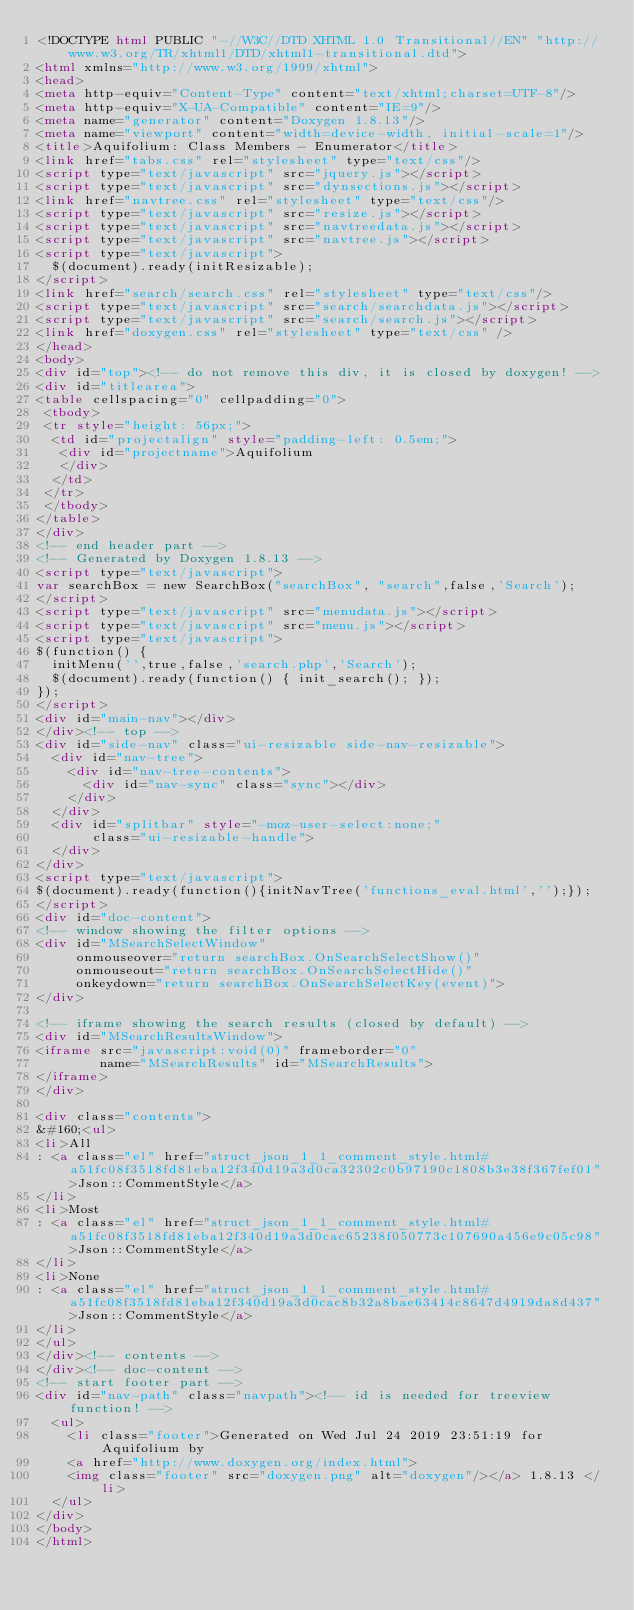Convert code to text. <code><loc_0><loc_0><loc_500><loc_500><_HTML_><!DOCTYPE html PUBLIC "-//W3C//DTD XHTML 1.0 Transitional//EN" "http://www.w3.org/TR/xhtml1/DTD/xhtml1-transitional.dtd">
<html xmlns="http://www.w3.org/1999/xhtml">
<head>
<meta http-equiv="Content-Type" content="text/xhtml;charset=UTF-8"/>
<meta http-equiv="X-UA-Compatible" content="IE=9"/>
<meta name="generator" content="Doxygen 1.8.13"/>
<meta name="viewport" content="width=device-width, initial-scale=1"/>
<title>Aquifolium: Class Members - Enumerator</title>
<link href="tabs.css" rel="stylesheet" type="text/css"/>
<script type="text/javascript" src="jquery.js"></script>
<script type="text/javascript" src="dynsections.js"></script>
<link href="navtree.css" rel="stylesheet" type="text/css"/>
<script type="text/javascript" src="resize.js"></script>
<script type="text/javascript" src="navtreedata.js"></script>
<script type="text/javascript" src="navtree.js"></script>
<script type="text/javascript">
  $(document).ready(initResizable);
</script>
<link href="search/search.css" rel="stylesheet" type="text/css"/>
<script type="text/javascript" src="search/searchdata.js"></script>
<script type="text/javascript" src="search/search.js"></script>
<link href="doxygen.css" rel="stylesheet" type="text/css" />
</head>
<body>
<div id="top"><!-- do not remove this div, it is closed by doxygen! -->
<div id="titlearea">
<table cellspacing="0" cellpadding="0">
 <tbody>
 <tr style="height: 56px;">
  <td id="projectalign" style="padding-left: 0.5em;">
   <div id="projectname">Aquifolium
   </div>
  </td>
 </tr>
 </tbody>
</table>
</div>
<!-- end header part -->
<!-- Generated by Doxygen 1.8.13 -->
<script type="text/javascript">
var searchBox = new SearchBox("searchBox", "search",false,'Search');
</script>
<script type="text/javascript" src="menudata.js"></script>
<script type="text/javascript" src="menu.js"></script>
<script type="text/javascript">
$(function() {
  initMenu('',true,false,'search.php','Search');
  $(document).ready(function() { init_search(); });
});
</script>
<div id="main-nav"></div>
</div><!-- top -->
<div id="side-nav" class="ui-resizable side-nav-resizable">
  <div id="nav-tree">
    <div id="nav-tree-contents">
      <div id="nav-sync" class="sync"></div>
    </div>
  </div>
  <div id="splitbar" style="-moz-user-select:none;" 
       class="ui-resizable-handle">
  </div>
</div>
<script type="text/javascript">
$(document).ready(function(){initNavTree('functions_eval.html','');});
</script>
<div id="doc-content">
<!-- window showing the filter options -->
<div id="MSearchSelectWindow"
     onmouseover="return searchBox.OnSearchSelectShow()"
     onmouseout="return searchBox.OnSearchSelectHide()"
     onkeydown="return searchBox.OnSearchSelectKey(event)">
</div>

<!-- iframe showing the search results (closed by default) -->
<div id="MSearchResultsWindow">
<iframe src="javascript:void(0)" frameborder="0" 
        name="MSearchResults" id="MSearchResults">
</iframe>
</div>

<div class="contents">
&#160;<ul>
<li>All
: <a class="el" href="struct_json_1_1_comment_style.html#a51fc08f3518fd81eba12f340d19a3d0ca32302c0b97190c1808b3e38f367fef01">Json::CommentStyle</a>
</li>
<li>Most
: <a class="el" href="struct_json_1_1_comment_style.html#a51fc08f3518fd81eba12f340d19a3d0cac65238f050773c107690a456e9c05c98">Json::CommentStyle</a>
</li>
<li>None
: <a class="el" href="struct_json_1_1_comment_style.html#a51fc08f3518fd81eba12f340d19a3d0cac8b32a8bae63414c8647d4919da8d437">Json::CommentStyle</a>
</li>
</ul>
</div><!-- contents -->
</div><!-- doc-content -->
<!-- start footer part -->
<div id="nav-path" class="navpath"><!-- id is needed for treeview function! -->
  <ul>
    <li class="footer">Generated on Wed Jul 24 2019 23:51:19 for Aquifolium by
    <a href="http://www.doxygen.org/index.html">
    <img class="footer" src="doxygen.png" alt="doxygen"/></a> 1.8.13 </li>
  </ul>
</div>
</body>
</html>
</code> 